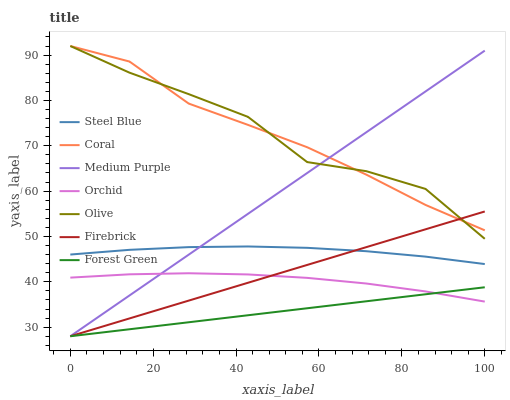Does Forest Green have the minimum area under the curve?
Answer yes or no. Yes. Does Olive have the maximum area under the curve?
Answer yes or no. Yes. Does Steel Blue have the minimum area under the curve?
Answer yes or no. No. Does Steel Blue have the maximum area under the curve?
Answer yes or no. No. Is Forest Green the smoothest?
Answer yes or no. Yes. Is Olive the roughest?
Answer yes or no. Yes. Is Steel Blue the smoothest?
Answer yes or no. No. Is Steel Blue the roughest?
Answer yes or no. No. Does Medium Purple have the lowest value?
Answer yes or no. Yes. Does Steel Blue have the lowest value?
Answer yes or no. No. Does Olive have the highest value?
Answer yes or no. Yes. Does Steel Blue have the highest value?
Answer yes or no. No. Is Orchid less than Steel Blue?
Answer yes or no. Yes. Is Coral greater than Orchid?
Answer yes or no. Yes. Does Coral intersect Olive?
Answer yes or no. Yes. Is Coral less than Olive?
Answer yes or no. No. Is Coral greater than Olive?
Answer yes or no. No. Does Orchid intersect Steel Blue?
Answer yes or no. No. 